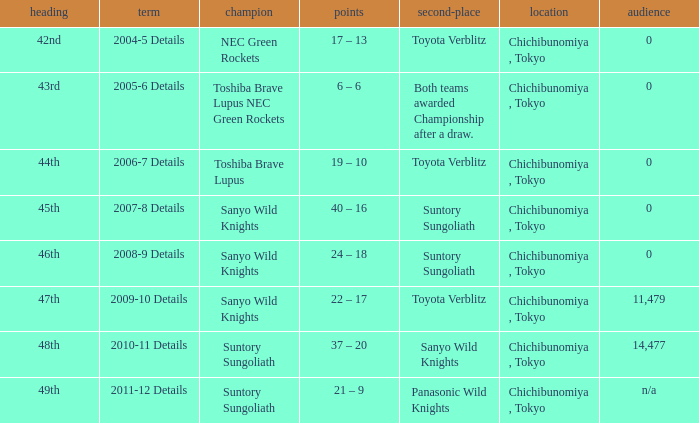What is the Attendance number when the runner-up was suntory sungoliath, and a Title of 46th? 0.0. 